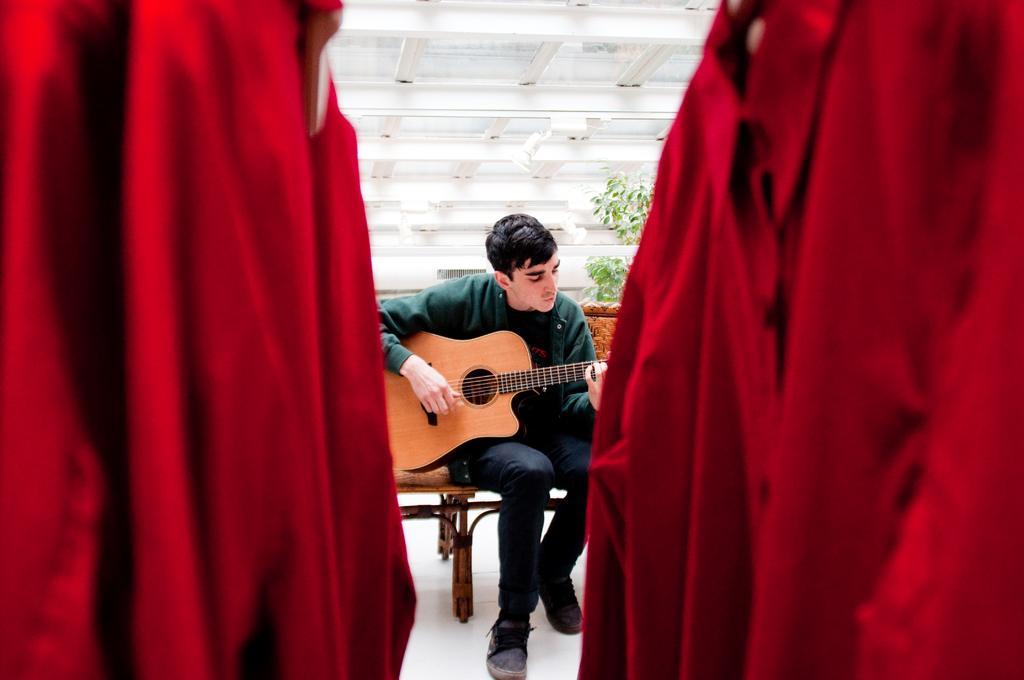Describe this image in one or two sentences. in this picture we can see a man is sitting on a chair, and playing guitar, and at back there is the tree, and in front there are some clothes. 